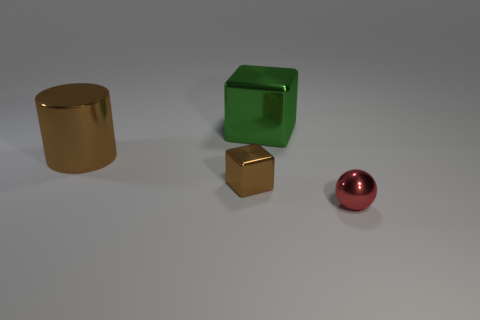Are there any large objects that have the same color as the small shiny cube?
Provide a short and direct response. Yes. There is a metal object that is both to the left of the green metal cube and to the right of the large brown shiny cylinder; how big is it?
Keep it short and to the point. Small. The small thing that is the same shape as the big green metal object is what color?
Offer a terse response. Brown. Is the number of things that are on the left side of the small red metal thing greater than the number of objects that are in front of the large metallic cube?
Your answer should be compact. No. How many other things are the same shape as the red metal object?
Provide a short and direct response. 0. Is there a red ball left of the tiny object that is to the right of the brown metallic cube?
Offer a very short reply. No. What number of large objects are there?
Your response must be concise. 2. Do the cylinder and the block in front of the green metallic block have the same color?
Provide a short and direct response. Yes. Is the number of tiny red objects greater than the number of big metal objects?
Provide a succinct answer. No. Is there anything else that has the same color as the large cylinder?
Offer a terse response. Yes. 